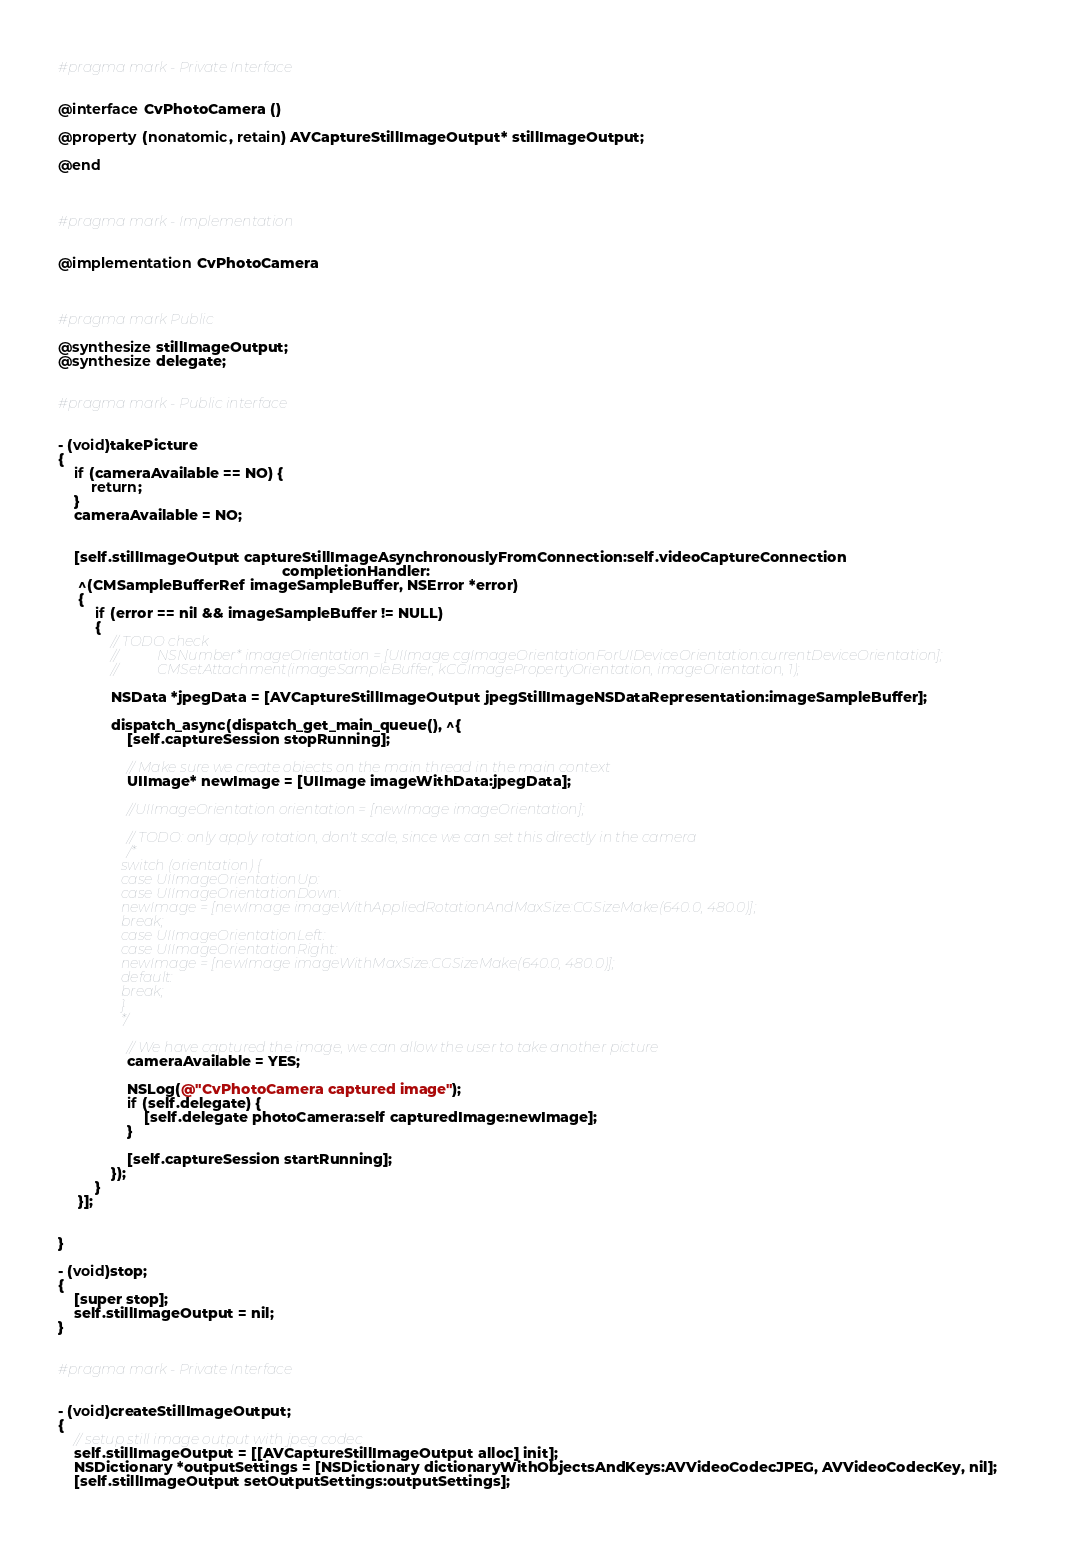Convert code to text. <code><loc_0><loc_0><loc_500><loc_500><_ObjectiveC_>#pragma mark - Private Interface


@interface CvPhotoCamera ()

@property (nonatomic, retain) AVCaptureStillImageOutput* stillImageOutput;

@end



#pragma mark - Implementation


@implementation CvPhotoCamera



#pragma mark Public

@synthesize stillImageOutput;
@synthesize delegate;


#pragma mark - Public interface


- (void)takePicture
{
    if (cameraAvailable == NO) {
        return;
    }
    cameraAvailable = NO;


    [self.stillImageOutput captureStillImageAsynchronouslyFromConnection:self.videoCaptureConnection
                                                       completionHandler:
     ^(CMSampleBufferRef imageSampleBuffer, NSError *error)
     {
         if (error == nil && imageSampleBuffer != NULL)
         {
             // TODO check
             //			 NSNumber* imageOrientation = [UIImage cgImageOrientationForUIDeviceOrientation:currentDeviceOrientation];
             //			 CMSetAttachment(imageSampleBuffer, kCGImagePropertyOrientation, imageOrientation, 1);

             NSData *jpegData = [AVCaptureStillImageOutput jpegStillImageNSDataRepresentation:imageSampleBuffer];

             dispatch_async(dispatch_get_main_queue(), ^{
                 [self.captureSession stopRunning];

                 // Make sure we create objects on the main thread in the main context
                 UIImage* newImage = [UIImage imageWithData:jpegData];

                 //UIImageOrientation orientation = [newImage imageOrientation];

                 // TODO: only apply rotation, don't scale, since we can set this directly in the camera
                 /*
                  switch (orientation) {
                  case UIImageOrientationUp:
                  case UIImageOrientationDown:
                  newImage = [newImage imageWithAppliedRotationAndMaxSize:CGSizeMake(640.0, 480.0)];
                  break;
                  case UIImageOrientationLeft:
                  case UIImageOrientationRight:
                  newImage = [newImage imageWithMaxSize:CGSizeMake(640.0, 480.0)];
                  default:
                  break;
                  }
                  */

                 // We have captured the image, we can allow the user to take another picture
                 cameraAvailable = YES;

                 NSLog(@"CvPhotoCamera captured image");
                 if (self.delegate) {
                     [self.delegate photoCamera:self capturedImage:newImage];
                 }

                 [self.captureSession startRunning];
             });
         }
     }];


}

- (void)stop;
{
    [super stop];
    self.stillImageOutput = nil;
}


#pragma mark - Private Interface


- (void)createStillImageOutput;
{
    // setup still image output with jpeg codec
    self.stillImageOutput = [[AVCaptureStillImageOutput alloc] init];
    NSDictionary *outputSettings = [NSDictionary dictionaryWithObjectsAndKeys:AVVideoCodecJPEG, AVVideoCodecKey, nil];
    [self.stillImageOutput setOutputSettings:outputSettings];</code> 